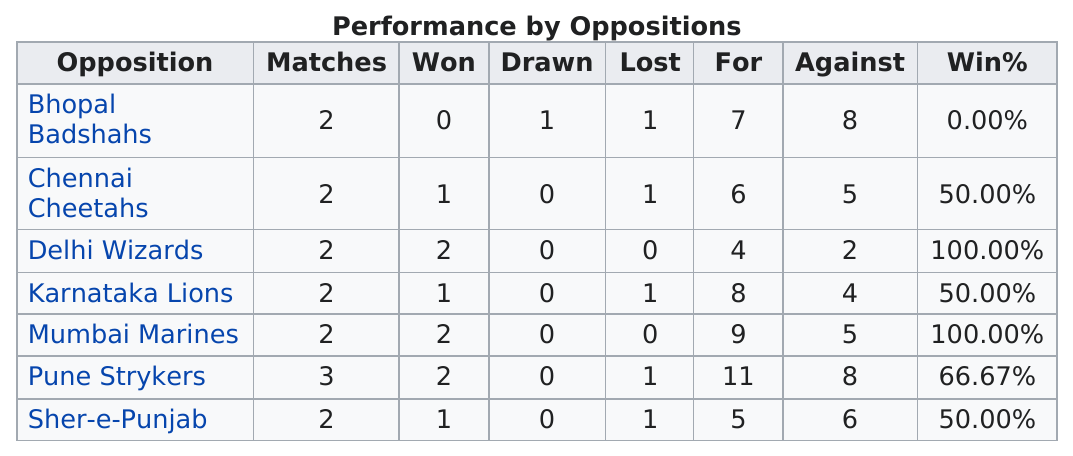Specify some key components in this picture. Delhi Wizards, Mumbai Marines, and Pune Strykers are the top winners among the three teams in the competition. There are no oppositions in which the Chandigarh Comets have a 100% win rate against 2 or more opponents. Out of the teams that won less than the Pune Strykers, 4 teams won less than them. The Mumbai Marines have the same percentage as the Delhi Wizards. The Bhopal Badshahs were the only team that the Comets did not defeat during the entire tournament. 